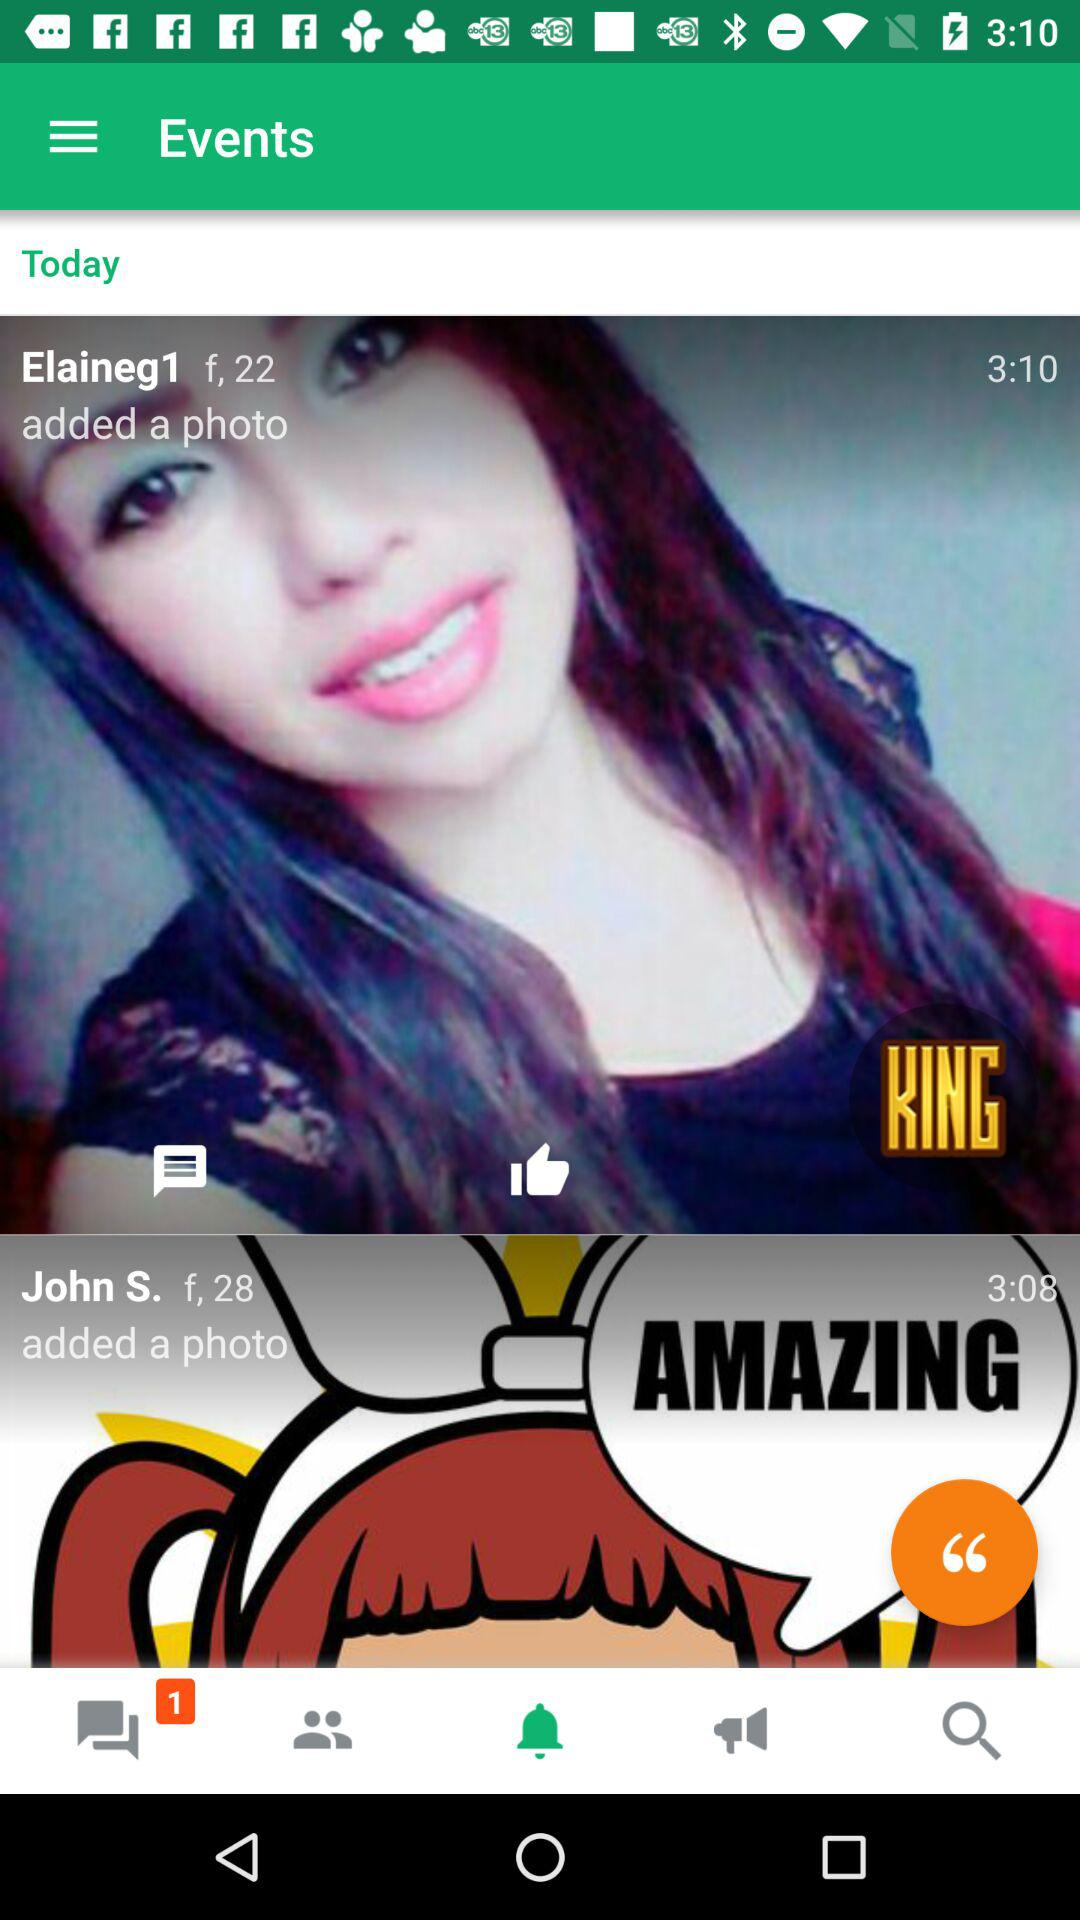How many unread messages are there? There is 1 unread message. 